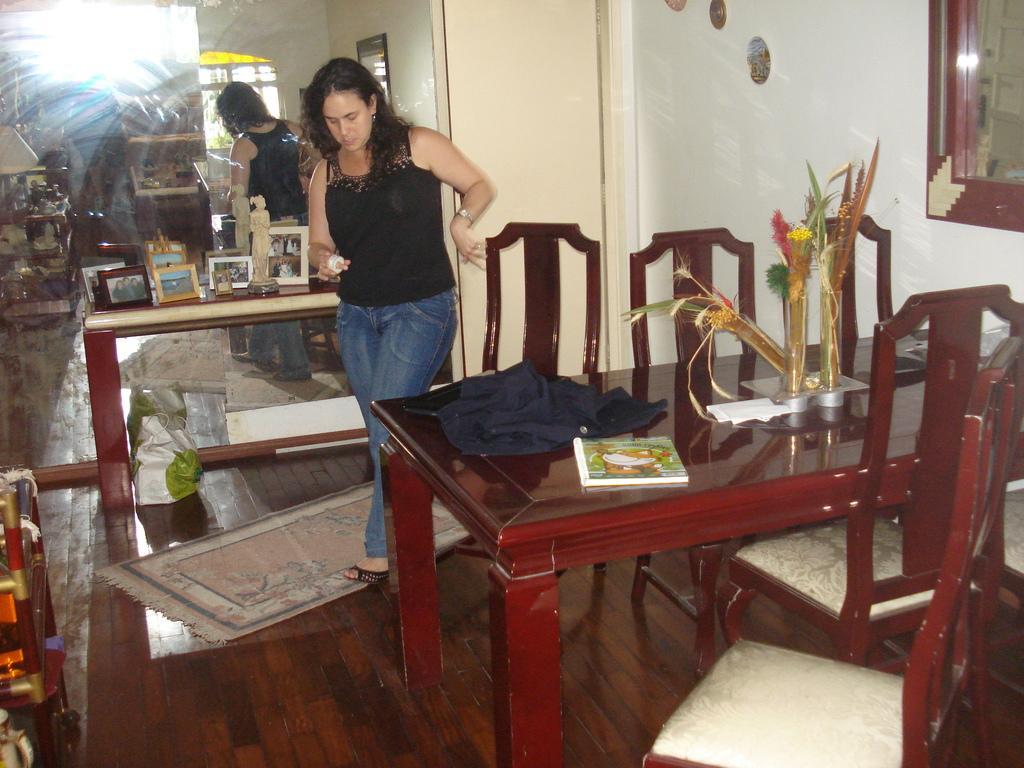Please provide a concise description of this image. In the picture there is a room in which a woman is walking there is a table and chairs near the women on the table there is a jacket books and a house plan there is a mirror behind women near to the mirror there is a table on the table there are many photo frames there is a mat on the floor. 